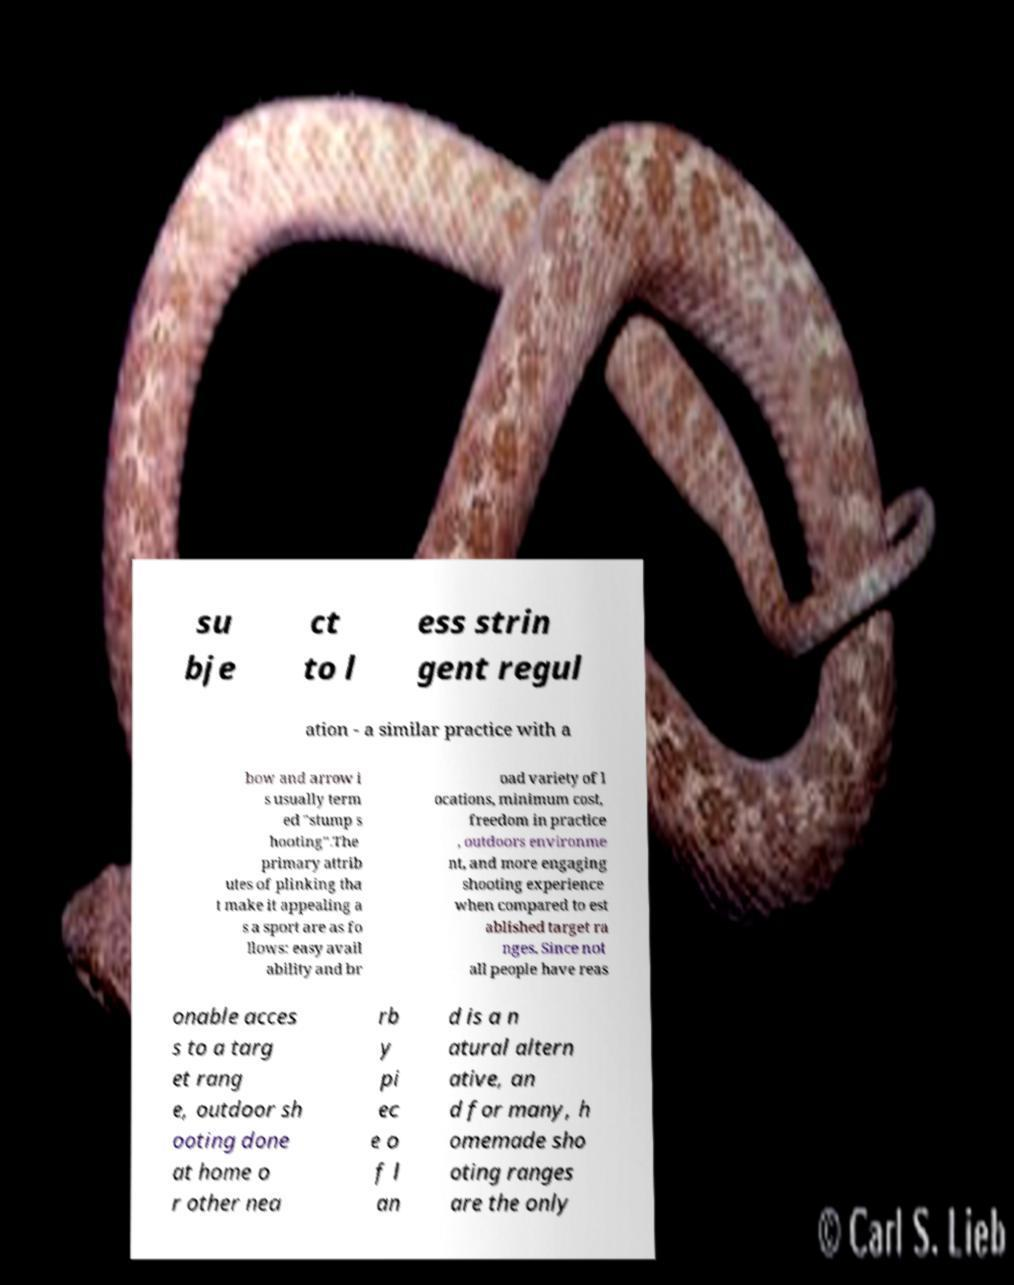What messages or text are displayed in this image? I need them in a readable, typed format. su bje ct to l ess strin gent regul ation - a similar practice with a bow and arrow i s usually term ed "stump s hooting".The primary attrib utes of plinking tha t make it appealing a s a sport are as fo llows: easy avail ability and br oad variety of l ocations, minimum cost, freedom in practice , outdoors environme nt, and more engaging shooting experience when compared to est ablished target ra nges. Since not all people have reas onable acces s to a targ et rang e, outdoor sh ooting done at home o r other nea rb y pi ec e o f l an d is a n atural altern ative, an d for many, h omemade sho oting ranges are the only 